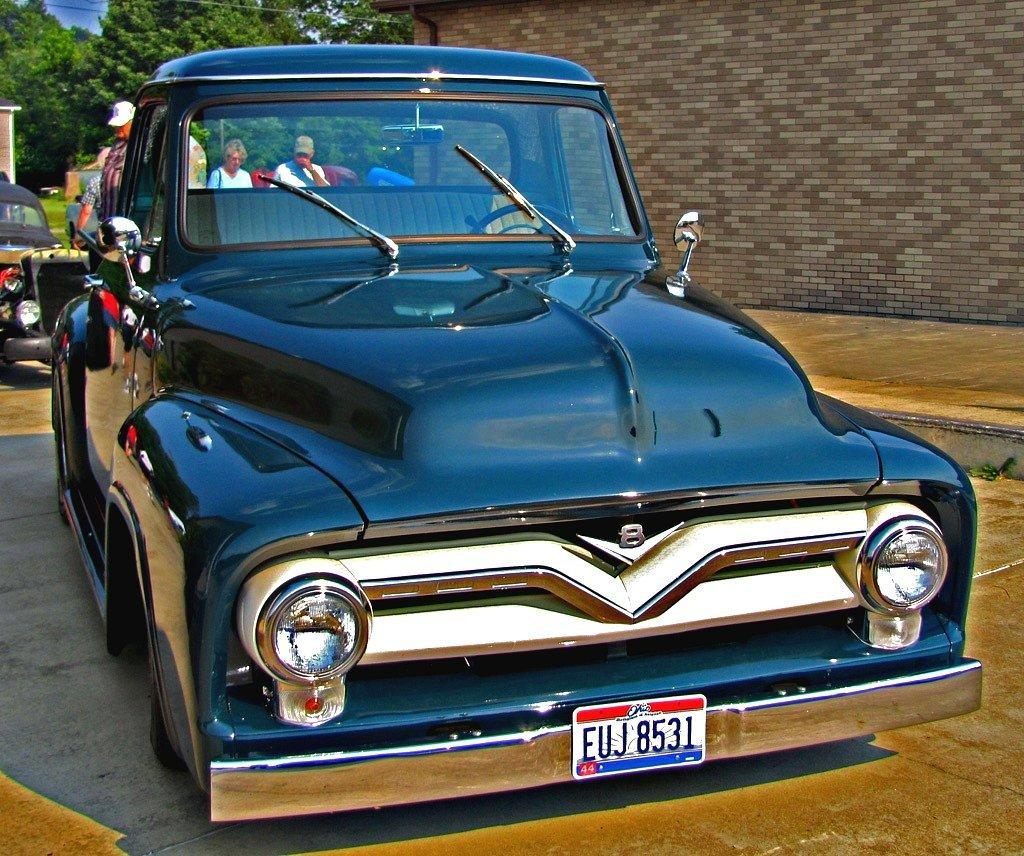What can be seen on the path in the image? There are vehicles on the path in the image. Who or what else is present in the image? There are people in the image. What type of natural elements can be seen in the image? Trees are visible in the image. What is located on the right side of the image? A wall is visible on the right side of the image. What type of boot can be seen on the chicken in the image? There is no chicken or boot present in the image. What noise is being made by the vehicles in the image? The image does not provide any information about the noise made by the vehicles; it only shows their presence on the path. 